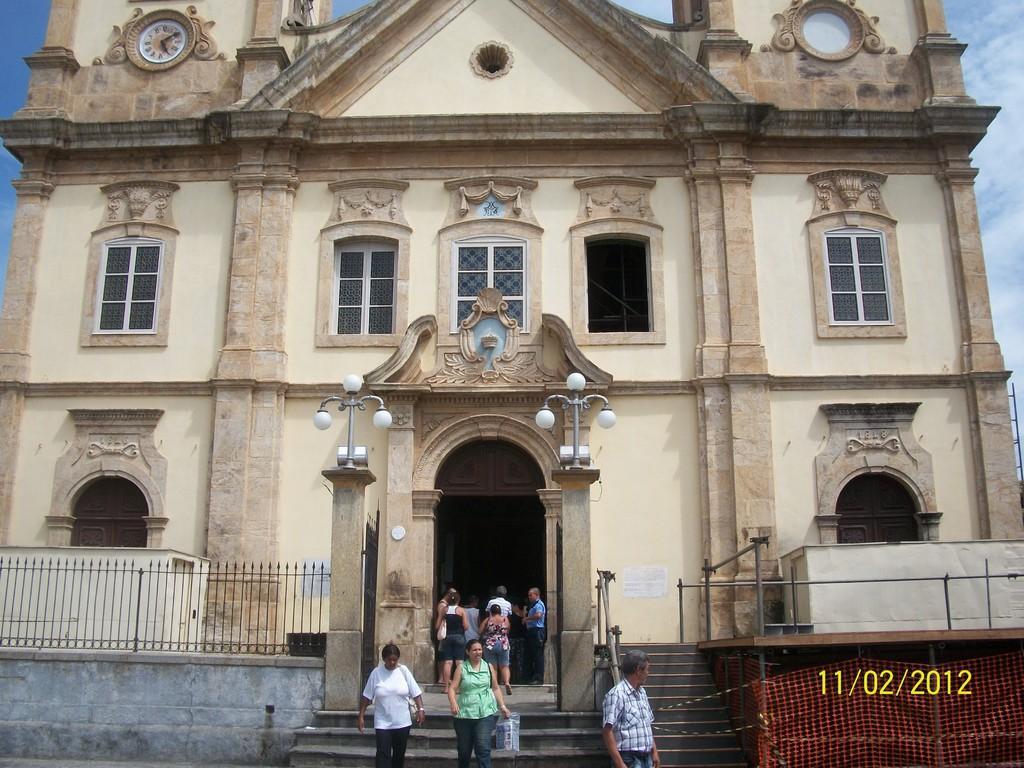Please provide a concise description of this image. In this image in the center there are persons standing and walking. In the background there is a building and in front of the building there is a fence and on the left side on the top of the building there is a clock and the sky is cloudy. 